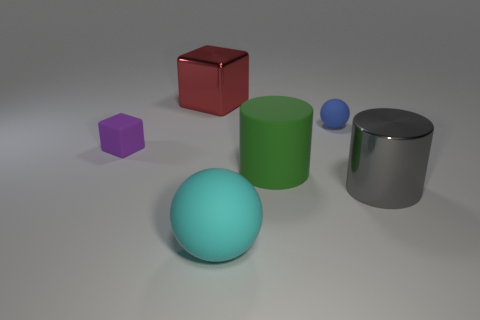Add 2 cyan matte cylinders. How many objects exist? 8 Subtract all cubes. How many objects are left? 4 Subtract all tiny green matte spheres. Subtract all small matte cubes. How many objects are left? 5 Add 6 big metal blocks. How many big metal blocks are left? 7 Add 1 big red spheres. How many big red spheres exist? 1 Subtract 1 blue spheres. How many objects are left? 5 